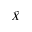Convert formula to latex. <formula><loc_0><loc_0><loc_500><loc_500>\tilde { X }</formula> 